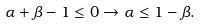<formula> <loc_0><loc_0><loc_500><loc_500>\alpha + \beta - 1 \leq 0 \rightarrow \alpha \leq 1 - \beta .</formula> 